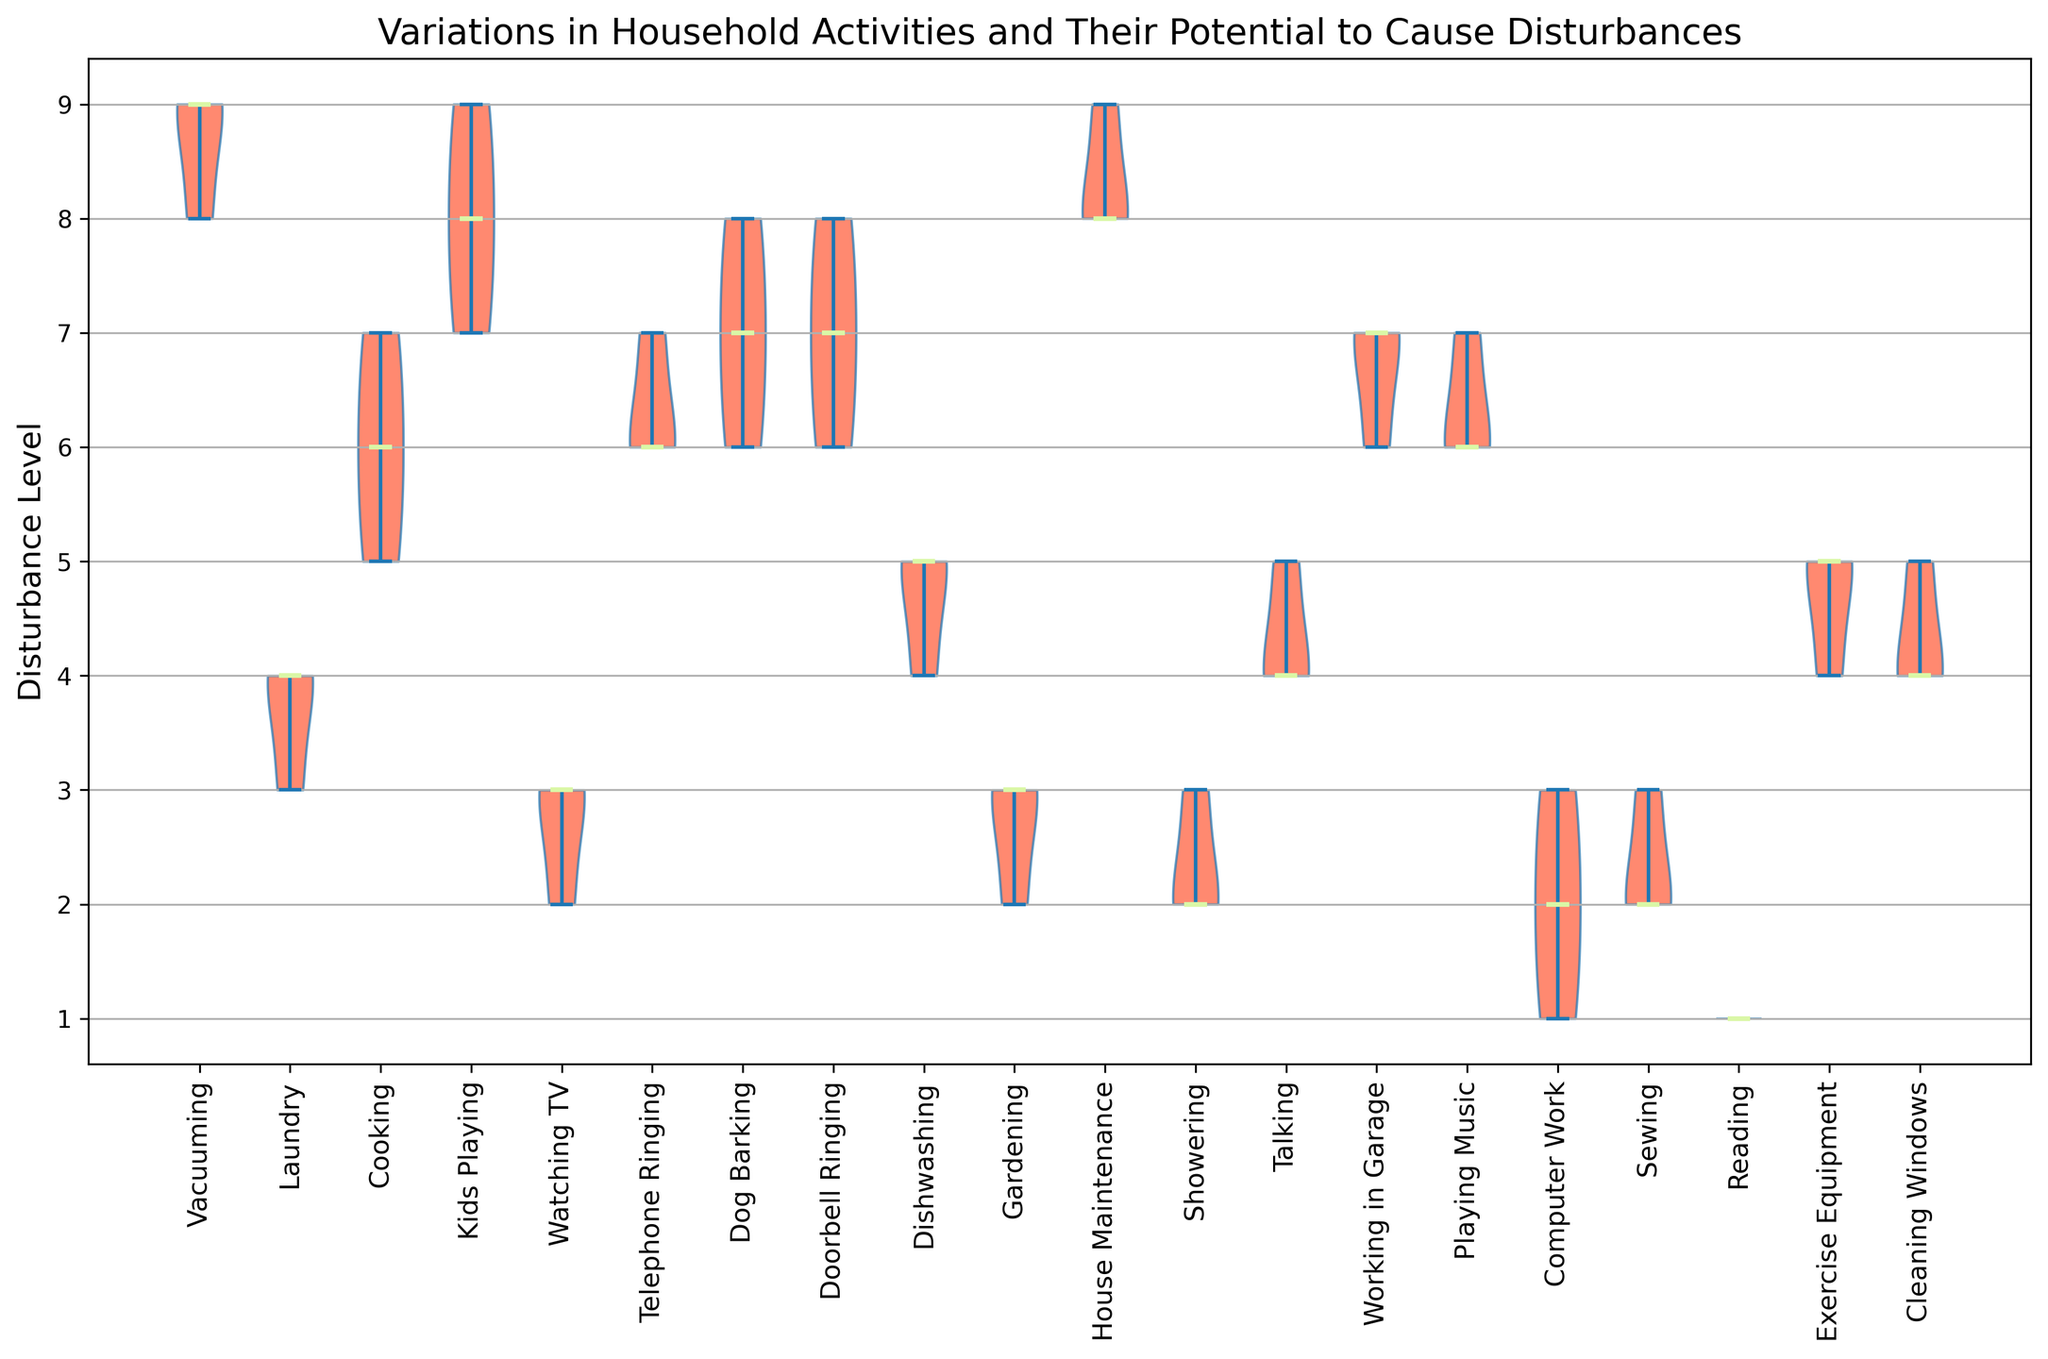What is the median disturbance level for 'Vacuuming'? To find the median disturbance level for 'Vacuuming', look at the horizontal line within the violin for 'Vacuuming'. This line represents the median.
Answer: 9 Which activity has the highest median disturbance level? Identify the longest horizontal line within the violins representing the median. The activity with this longest line has the highest median disturbance level.
Answer: House Maintenance Which activity has the lowest median disturbance level? Identify the shortest horizontal line within the violins representing the median. The activity with this shortest line has the lowest median disturbance level.
Answer: Reading Compare the median disturbance levels of 'Kids Playing' and 'Showering'. Which one is higher? Look at the horizontal lines within the violins for 'Kids Playing' and 'Showering' that represent the medians. The one with a higher position on the y-axis is higher.
Answer: Kids Playing What is the interquartile range (IQR) for 'Playing Music'? IQR can be estimated by identifying the range covered by the bulk of the data in the violin for 'Playing Music'. This is generally the width of the thick part of the violin.
Answer: Approx. 5 to 7 (estimate based on visual cues) Are there any activities with a disturbance level consistently high (values mostly high) across the board? Look for violins that are entirely or almost entirely located at the upper end of the y-axis.
Answer: House Maintenance and Kids Playing Which activities have median disturbance levels above 5? Identify the violin plots where the horizontal median line is above the numerical value of 5 on the y-axis.
Answer: Vacuuming, Kids Playing, House Maintenance, Dog Barking, Telephone Ringing, Playing Music, Working in Garage Is there more variability in disturbance levels for 'Cooking' or 'Laundry'? Compare the width and spread of the violins for 'Cooking' and 'Laundry'. The one with wider and more spread out shape indicates higher variability.
Answer: Cooking Which activity has a median disturbance level closest to 4? Identify the violin whose horizontal median line is closest to the numerical value of 4 on the y-axis.
Answer: Laundry Compare the medians of 'Dog Barking' and 'Telephone Ringing'. Are they equal? Examine the horizontal median lines within the violins for 'Dog Barking' and 'Telephone Ringing'. If the lines are at the same y-axis level, then they are equal.
Answer: Yes 